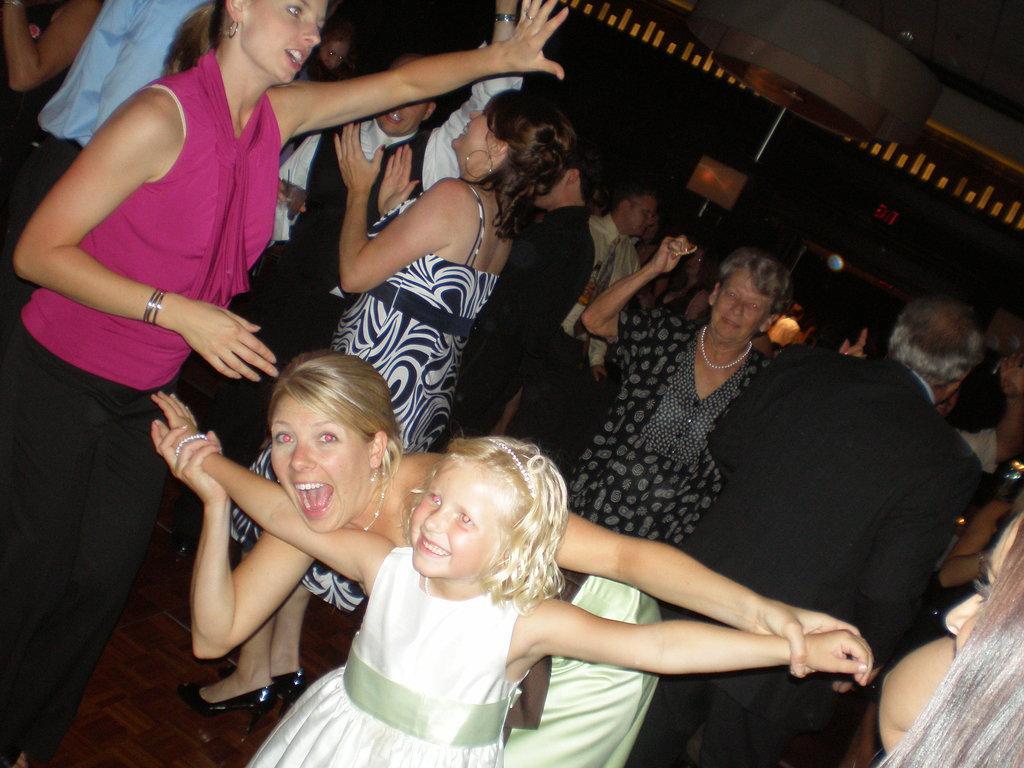How would you summarize this image in a sentence or two? In the middle of the image there is a girl with white frock is standing and she is smiling. Behind her there is a lady. And behind them there are many people dancing. And there is a black background with few lights. 